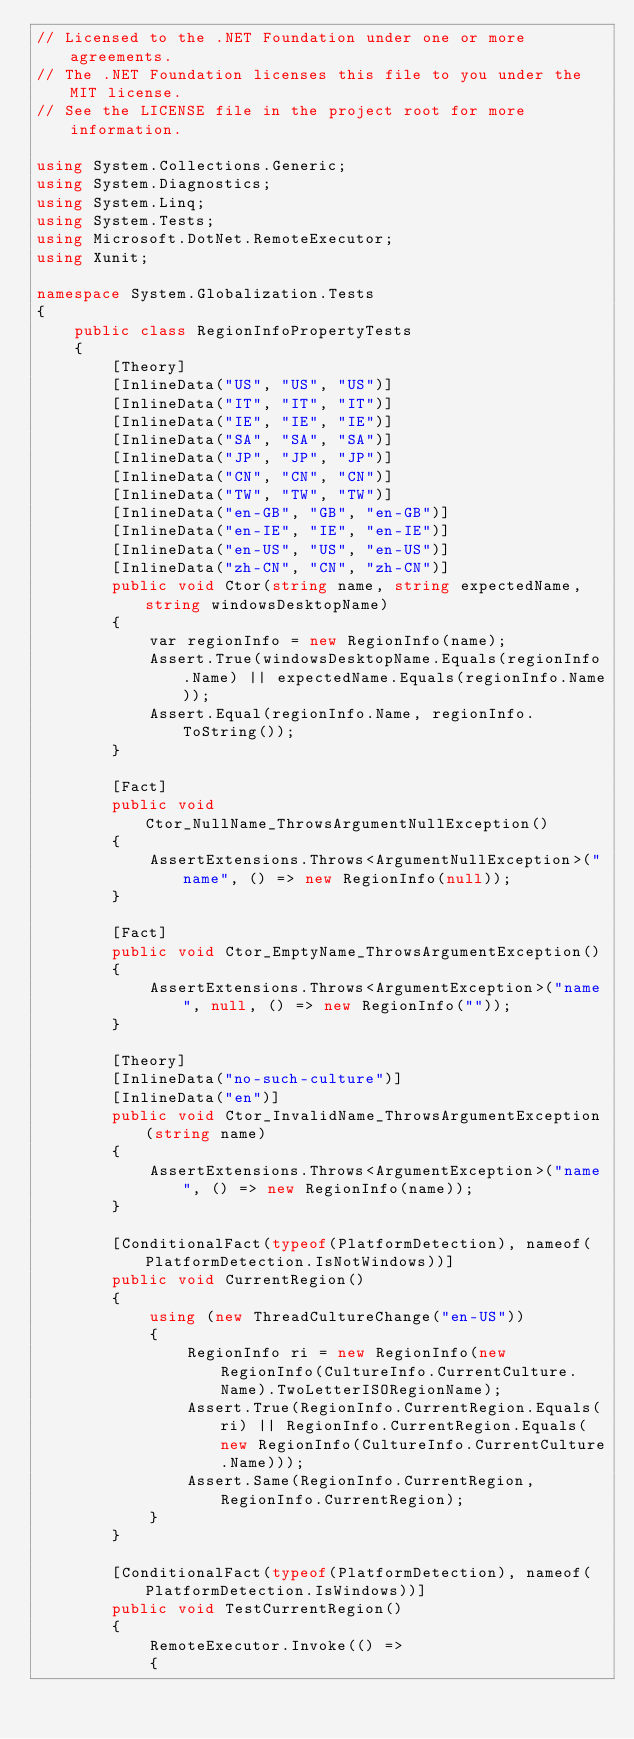<code> <loc_0><loc_0><loc_500><loc_500><_C#_>// Licensed to the .NET Foundation under one or more agreements.
// The .NET Foundation licenses this file to you under the MIT license.
// See the LICENSE file in the project root for more information.

using System.Collections.Generic;
using System.Diagnostics;
using System.Linq;
using System.Tests;
using Microsoft.DotNet.RemoteExecutor;
using Xunit;

namespace System.Globalization.Tests
{
    public class RegionInfoPropertyTests
    {
        [Theory]
        [InlineData("US", "US", "US")]
        [InlineData("IT", "IT", "IT")]
        [InlineData("IE", "IE", "IE")]
        [InlineData("SA", "SA", "SA")]
        [InlineData("JP", "JP", "JP")]
        [InlineData("CN", "CN", "CN")]
        [InlineData("TW", "TW", "TW")]
        [InlineData("en-GB", "GB", "en-GB")]
        [InlineData("en-IE", "IE", "en-IE")]
        [InlineData("en-US", "US", "en-US")]
        [InlineData("zh-CN", "CN", "zh-CN")]
        public void Ctor(string name, string expectedName, string windowsDesktopName)
        {
            var regionInfo = new RegionInfo(name);
            Assert.True(windowsDesktopName.Equals(regionInfo.Name) || expectedName.Equals(regionInfo.Name));
            Assert.Equal(regionInfo.Name, regionInfo.ToString());
        }

        [Fact]
        public void Ctor_NullName_ThrowsArgumentNullException()
        {
            AssertExtensions.Throws<ArgumentNullException>("name", () => new RegionInfo(null));
        }

        [Fact]
        public void Ctor_EmptyName_ThrowsArgumentException()
        {
            AssertExtensions.Throws<ArgumentException>("name", null, () => new RegionInfo(""));
        }

        [Theory]
        [InlineData("no-such-culture")]
        [InlineData("en")]
        public void Ctor_InvalidName_ThrowsArgumentException(string name)
        {
            AssertExtensions.Throws<ArgumentException>("name", () => new RegionInfo(name));
        }

        [ConditionalFact(typeof(PlatformDetection), nameof(PlatformDetection.IsNotWindows))]
        public void CurrentRegion()
        {
            using (new ThreadCultureChange("en-US"))
            {
                RegionInfo ri = new RegionInfo(new RegionInfo(CultureInfo.CurrentCulture.Name).TwoLetterISORegionName);
                Assert.True(RegionInfo.CurrentRegion.Equals(ri) || RegionInfo.CurrentRegion.Equals(new RegionInfo(CultureInfo.CurrentCulture.Name)));
                Assert.Same(RegionInfo.CurrentRegion, RegionInfo.CurrentRegion);
            }
        }

        [ConditionalFact(typeof(PlatformDetection), nameof(PlatformDetection.IsWindows))]
        public void TestCurrentRegion()
        {
            RemoteExecutor.Invoke(() =>
            {</code> 